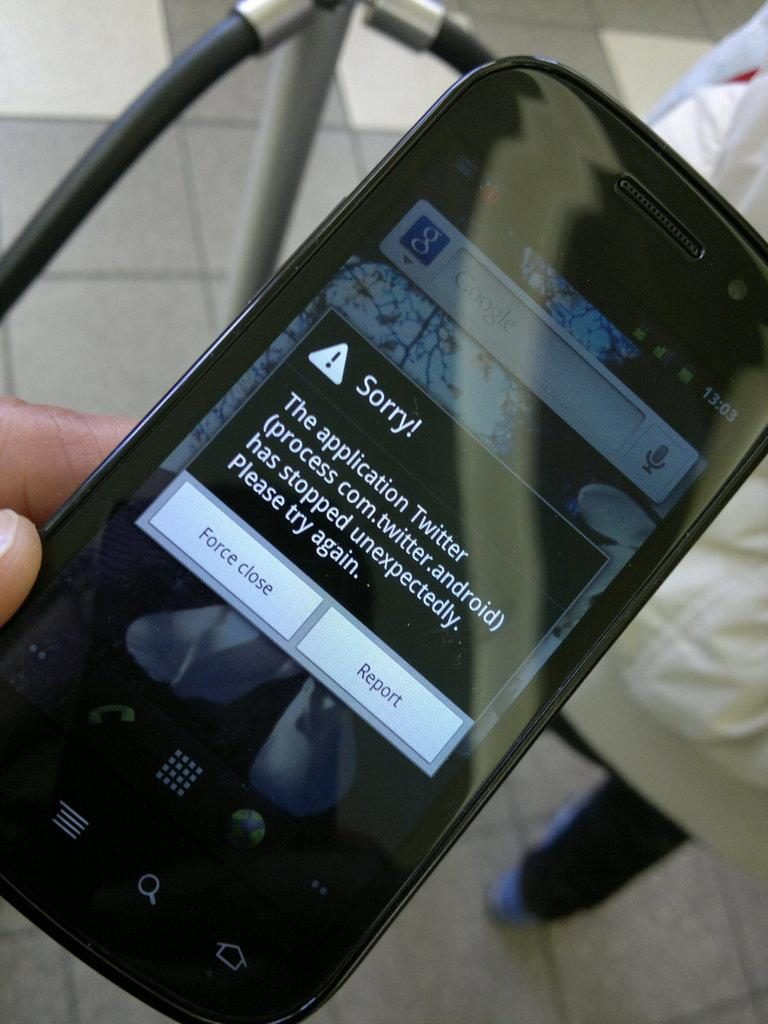What is the person holding in the image? There is a person's hand holding a mobile phone in the image. What can be seen on the mobile phone's screen? There is a pop-up visible on the mobile phone's screen. How many feet are visible in the image? There are no feet visible in the image; only a person's hand holding a mobile phone is present. 